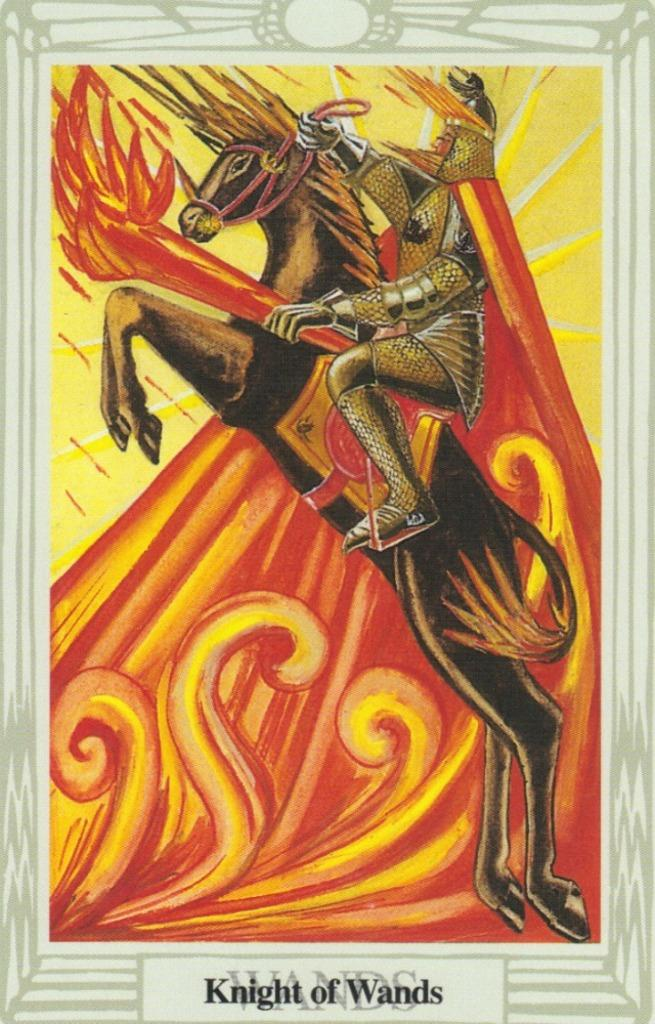What is the main subject of the poster in the image? The poster contains an image of a horse and a person. Can you describe the images on the poster? The poster contains an image of a horse and a person. Is there any text on the poster? Yes, there is text at the bottom of the poster. Can you tell me how many seashores are depicted on the poster? There are no seashores depicted on the poster; it features images of a horse and a person. What type of cast is shown interacting with the horse on the poster? There is no cast shown interacting with the horse on the poster; only the horse and person images are present. 